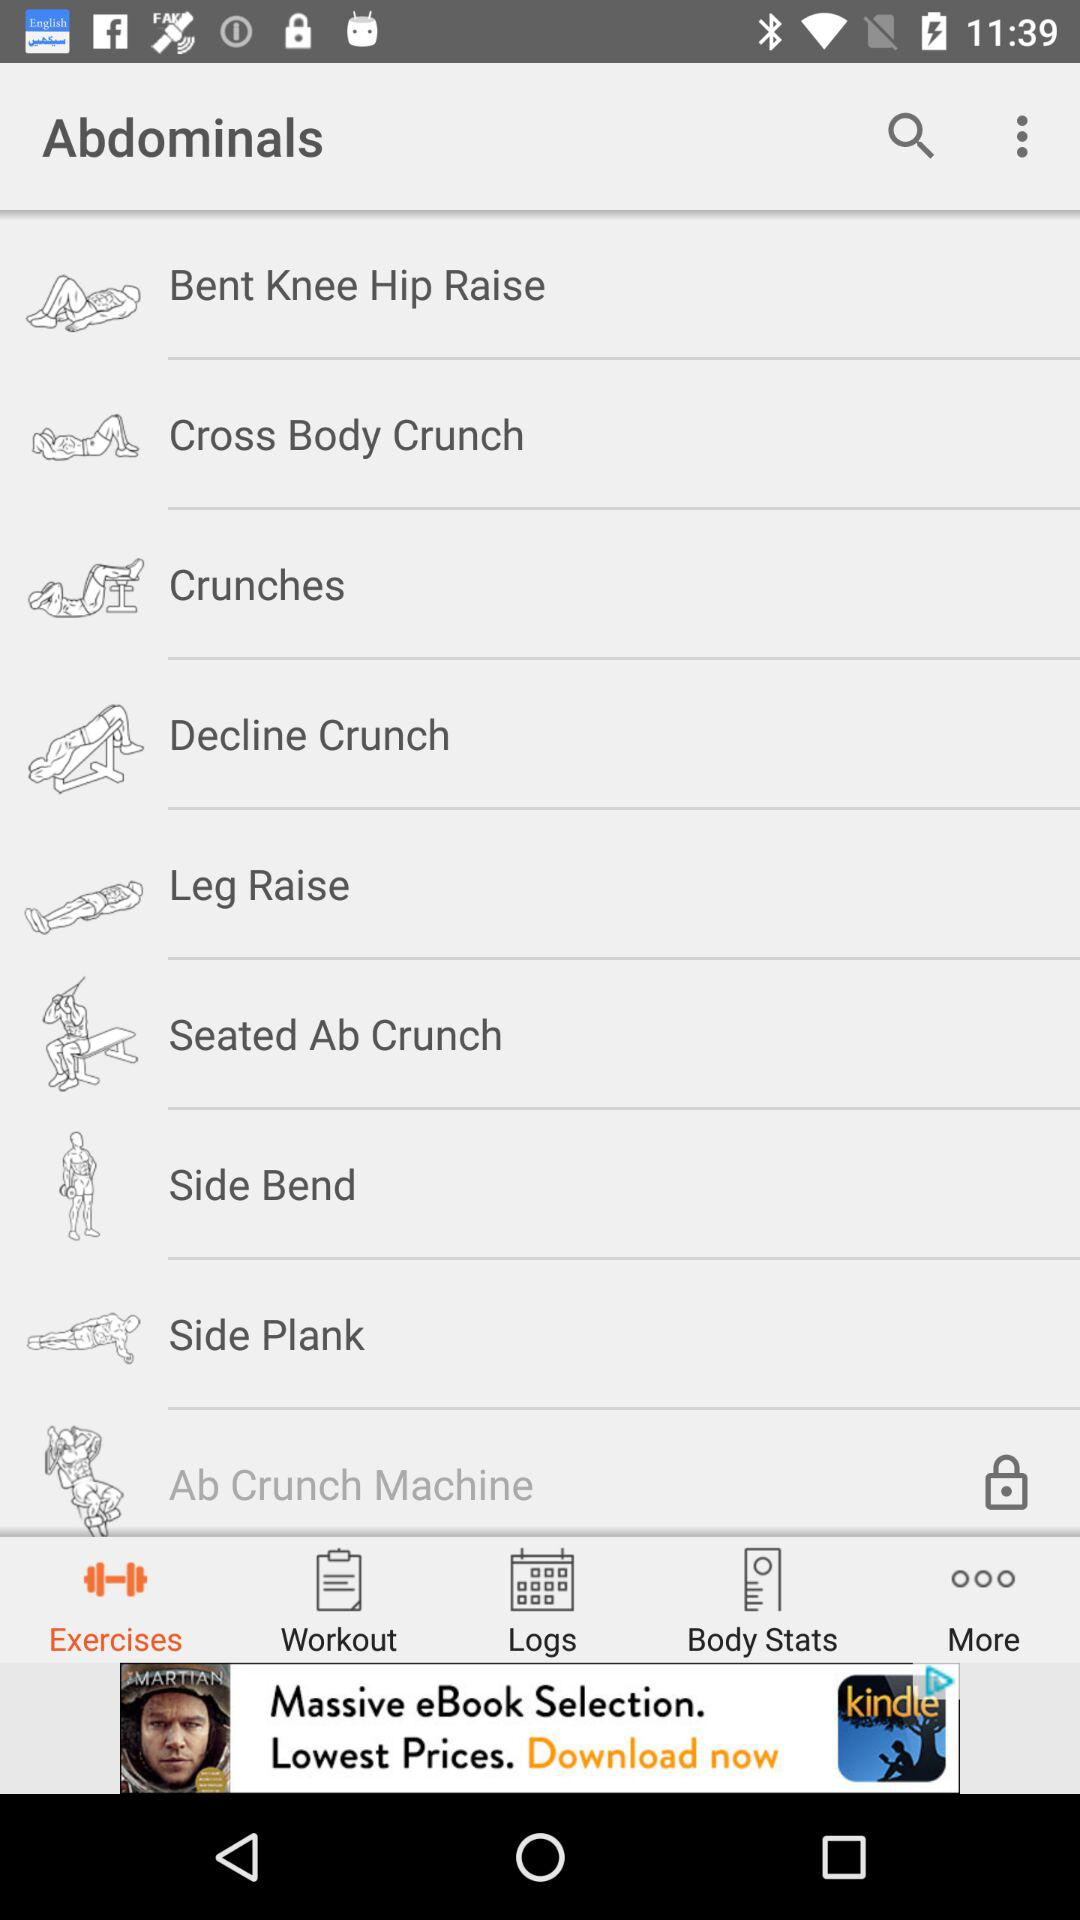What are the different types of abdominal exercises? The different types of abdominal exercises are bent knee hip raise, cross body crunch, crunches, decline crunch, leg raise, seated ab crunch, side bend, side plank and ab crunch machine. 